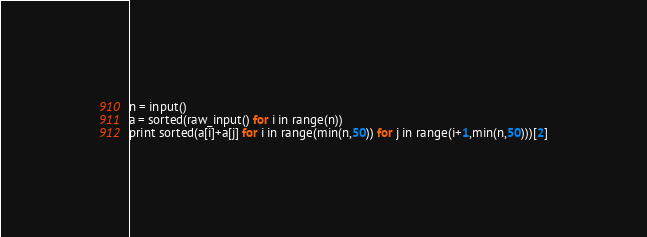<code> <loc_0><loc_0><loc_500><loc_500><_Python_>n = input()
a = sorted(raw_input() for i in range(n))
print sorted(a[i]+a[j] for i in range(min(n,50)) for j in range(i+1,min(n,50)))[2]</code> 